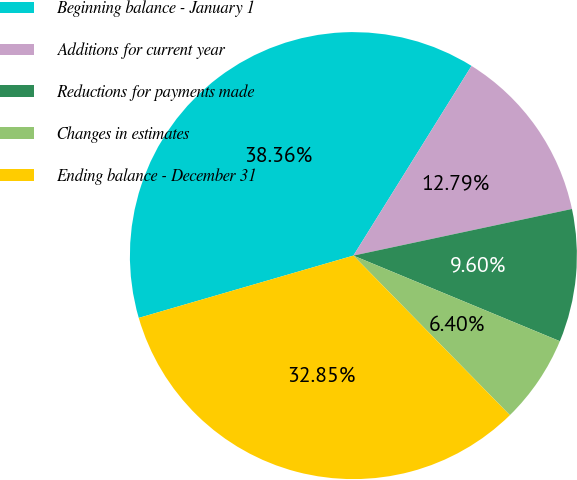Convert chart. <chart><loc_0><loc_0><loc_500><loc_500><pie_chart><fcel>Beginning balance - January 1<fcel>Additions for current year<fcel>Reductions for payments made<fcel>Changes in estimates<fcel>Ending balance - December 31<nl><fcel>38.36%<fcel>12.79%<fcel>9.6%<fcel>6.4%<fcel>32.85%<nl></chart> 